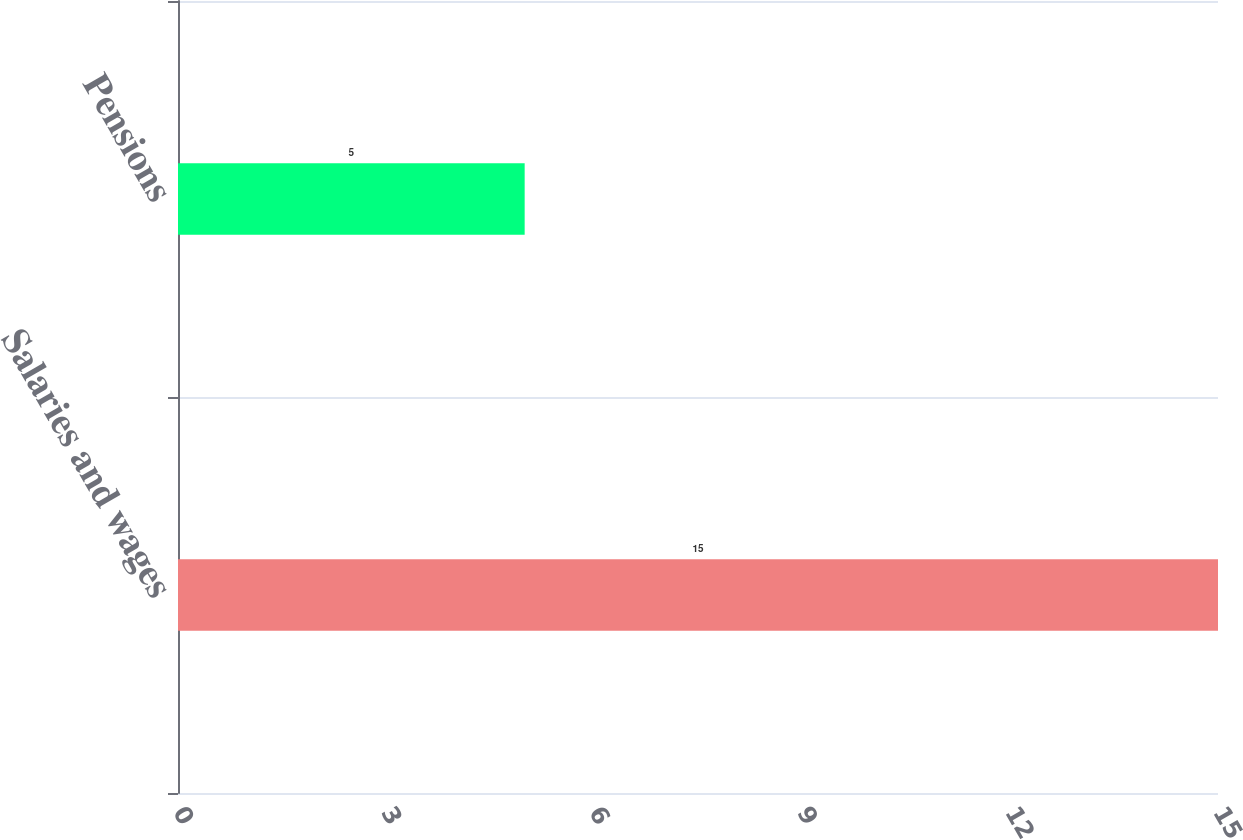Convert chart to OTSL. <chart><loc_0><loc_0><loc_500><loc_500><bar_chart><fcel>Salaries and wages<fcel>Pensions<nl><fcel>15<fcel>5<nl></chart> 